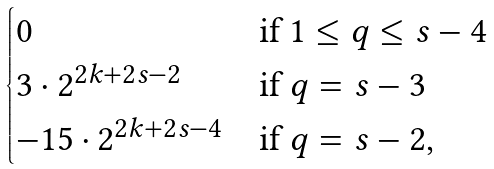<formula> <loc_0><loc_0><loc_500><loc_500>\begin{cases} 0 & \text {if } 1 \leq q \leq s - 4 \\ 3 \cdot 2 ^ { 2 k + 2 s - 2 } & \text {if } q = s - 3 \\ - 1 5 \cdot 2 ^ { 2 k + 2 s - 4 } & \text {if } q = s - 2 , \end{cases}</formula> 